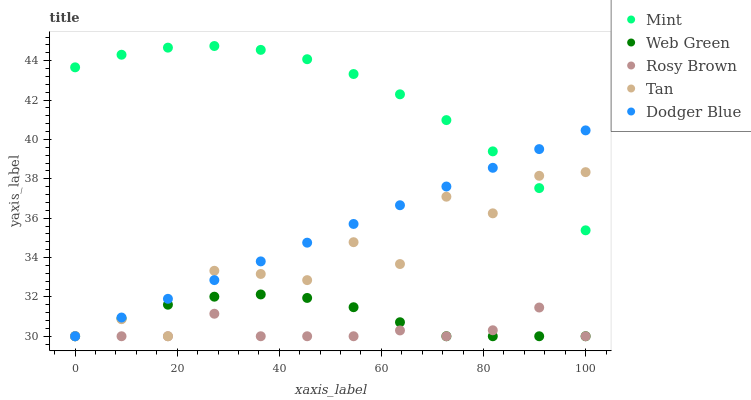Does Rosy Brown have the minimum area under the curve?
Answer yes or no. Yes. Does Mint have the maximum area under the curve?
Answer yes or no. Yes. Does Tan have the minimum area under the curve?
Answer yes or no. No. Does Tan have the maximum area under the curve?
Answer yes or no. No. Is Dodger Blue the smoothest?
Answer yes or no. Yes. Is Tan the roughest?
Answer yes or no. Yes. Is Rosy Brown the smoothest?
Answer yes or no. No. Is Rosy Brown the roughest?
Answer yes or no. No. Does Dodger Blue have the lowest value?
Answer yes or no. Yes. Does Mint have the lowest value?
Answer yes or no. No. Does Mint have the highest value?
Answer yes or no. Yes. Does Tan have the highest value?
Answer yes or no. No. Is Rosy Brown less than Mint?
Answer yes or no. Yes. Is Mint greater than Web Green?
Answer yes or no. Yes. Does Tan intersect Web Green?
Answer yes or no. Yes. Is Tan less than Web Green?
Answer yes or no. No. Is Tan greater than Web Green?
Answer yes or no. No. Does Rosy Brown intersect Mint?
Answer yes or no. No. 